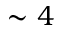<formula> <loc_0><loc_0><loc_500><loc_500>\sim 4</formula> 